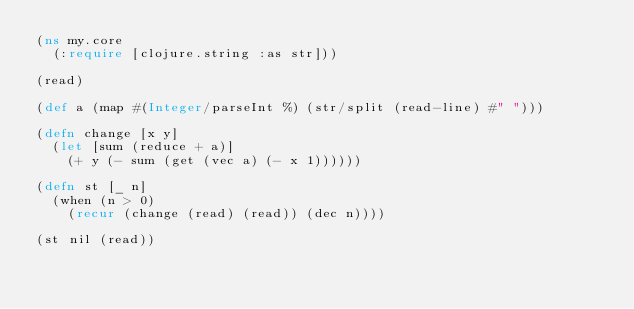Convert code to text. <code><loc_0><loc_0><loc_500><loc_500><_Clojure_>(ns my.core
  (:require [clojure.string :as str]))

(read)

(def a (map #(Integer/parseInt %) (str/split (read-line) #" ")))

(defn change [x y]
  (let [sum (reduce + a)]
    (+ y (- sum (get (vec a) (- x 1))))))

(defn st [_ n]
  (when (n > 0)
    (recur (change (read) (read)) (dec n))))

(st nil (read))</code> 